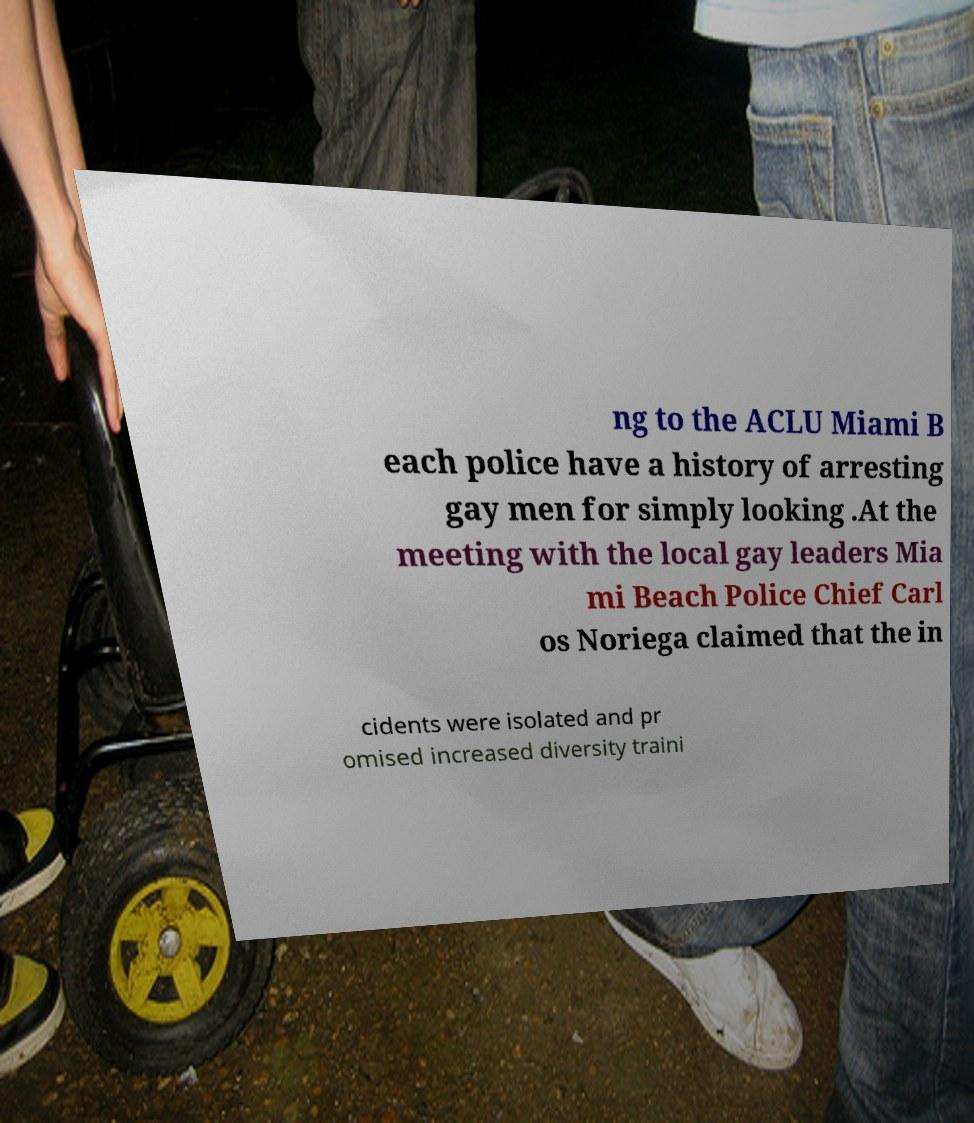For documentation purposes, I need the text within this image transcribed. Could you provide that? ng to the ACLU Miami B each police have a history of arresting gay men for simply looking .At the meeting with the local gay leaders Mia mi Beach Police Chief Carl os Noriega claimed that the in cidents were isolated and pr omised increased diversity traini 